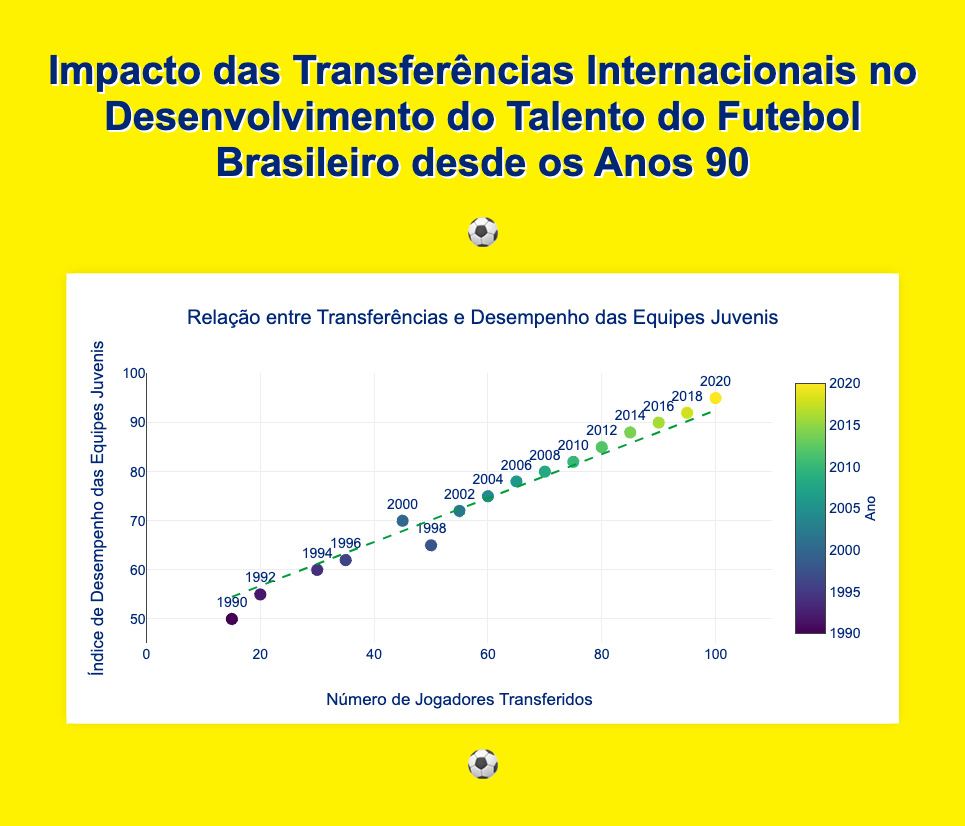How many players were transferred in the year 2000? Locate the data point with the year 2000, and look at the number of players transferred, which is shown by the x-axis value.
Answer: 45 Between which years did the Youth Teams Performance Index see the largest increase? Calculate the difference in the index between consecutive years. The largest increase is from 70 in 2000 to 72 in 2002.
Answer: 2000 to 2002 Which year had the lowest Youth Teams Performance Index? Identify the data point with the lowest y-axis value, which is the index value. The year 1990 has the lowest index of 50.
Answer: 1990 Is there a general trend between the number of players transferred and the Youth Teams Performance Index? Look at the trend line in the figure. It shows a positive slope, indicating that as the number of players transferred increases, the Youth Teams Performance Index also increases.
Answer: Positive trend What is the Youth Teams Performance Index in 2014? Find the data point labeled 2014, and read off the corresponding y-axis value for the index.
Answer: 88 By how much did the Youth Teams Performance Index change from 1990 to 2020? Subtract the 1990 index (50) from the 2020 index (95).
Answer: 45 Which year had the maximum number of players transferred? Identify the data point with the highest x-axis value for players transferred. The year 2020 had the highest number at 100.
Answer: 2020 At what number of players transferred does the trend line intersect the Youth Teams Performance Index of 75? Find where the trend line crosses the y-axis value of 75 and read the corresponding x-axis value for players transferred, which is approximately between 60 and 65.
Answer: Between 60 and 65 How many data points are there in the plot? Count the number of data points displayed in the scatter plot. There are 16 data points, corresponding to the years from 1990 to 2020.
Answer: 16 What is the average Youth Teams Performance Index from 1990 to 2000? Average the index values for 1990 (50), 1992 (55), 1994 (60), 1996 (62), 1998 (65), and 2000 (70). Summing them provides 362, and the average is 362/6.
Answer: 60.33 